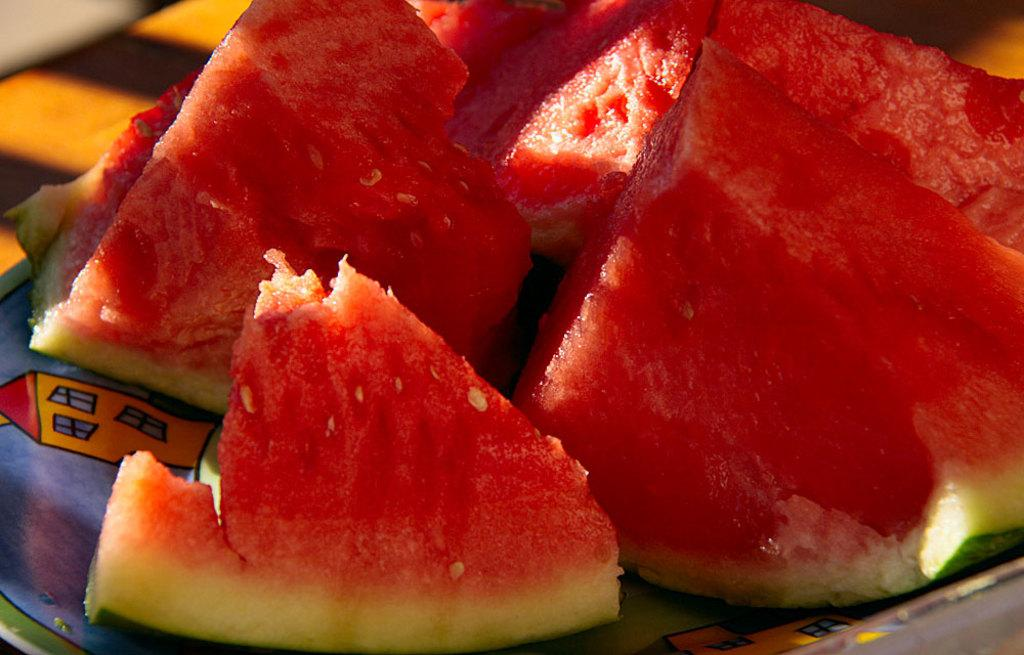What is present on the plate in the image? There are pieces of watermelon in the plate. Can you describe the main food item on the plate? The main food item on the plate is watermelon. What type of lumber is being used to build the table in the image? There is no table present in the image, so it is not possible to determine the type of lumber being used. 